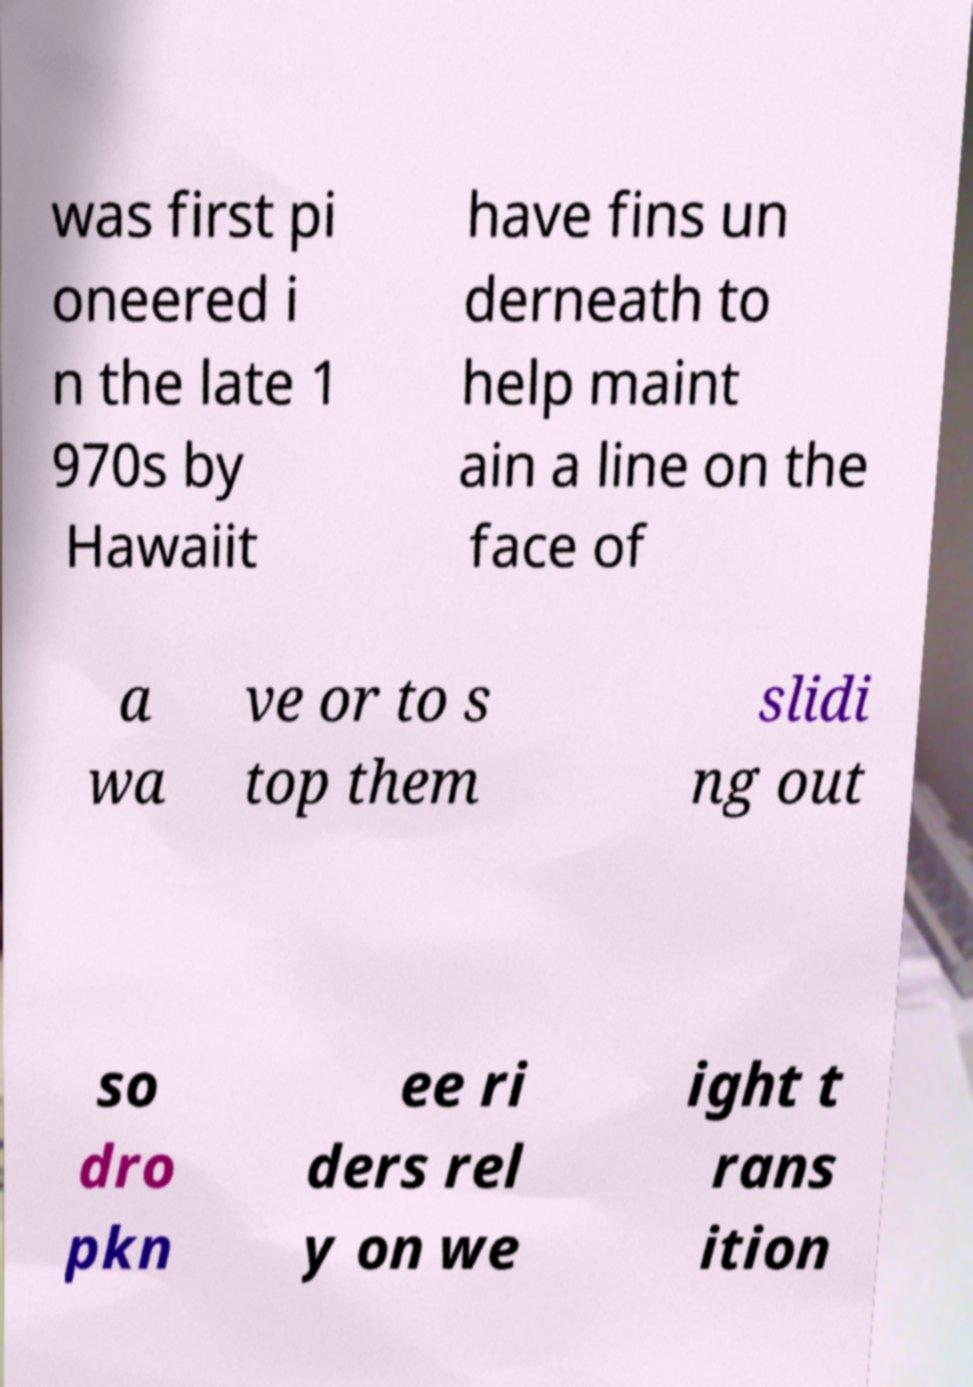Can you accurately transcribe the text from the provided image for me? was first pi oneered i n the late 1 970s by Hawaiit have fins un derneath to help maint ain a line on the face of a wa ve or to s top them slidi ng out so dro pkn ee ri ders rel y on we ight t rans ition 